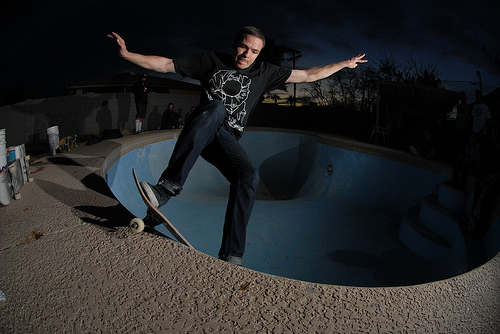How many people are pictured? The image captures a single individual performing a skateboarding trick inside an empty pool. 